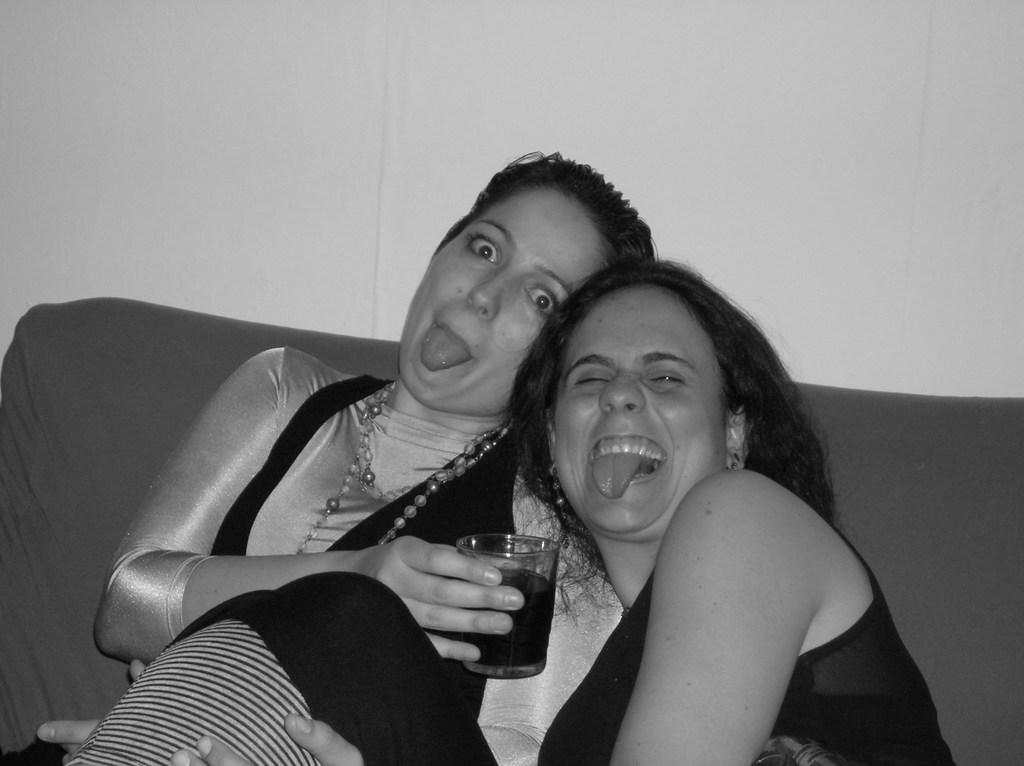What is the main subject of the image? The main subject of the image is the women in the center. Can you describe the expressions on their faces? The women have expressions on their faces, but the specific emotions cannot be determined from the image alone. What is the woman on the left side holding? The woman on the left side is holding a glass. What type of crime is being committed by the goldfish in the image? There is no goldfish present in the image, so it is not possible to determine if a crime is being committed. 